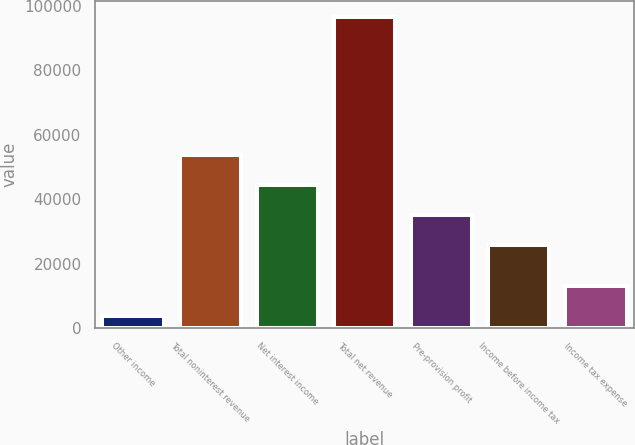<chart> <loc_0><loc_0><loc_500><loc_500><bar_chart><fcel>Other income<fcel>Total noninterest revenue<fcel>Net interest income<fcel>Total net revenue<fcel>Pre-provision profit<fcel>Income before income tax<fcel>Income tax expense<nl><fcel>3847<fcel>53741.7<fcel>44465.8<fcel>96606<fcel>35189.9<fcel>25914<fcel>13122.9<nl></chart> 